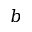Convert formula to latex. <formula><loc_0><loc_0><loc_500><loc_500>b</formula> 